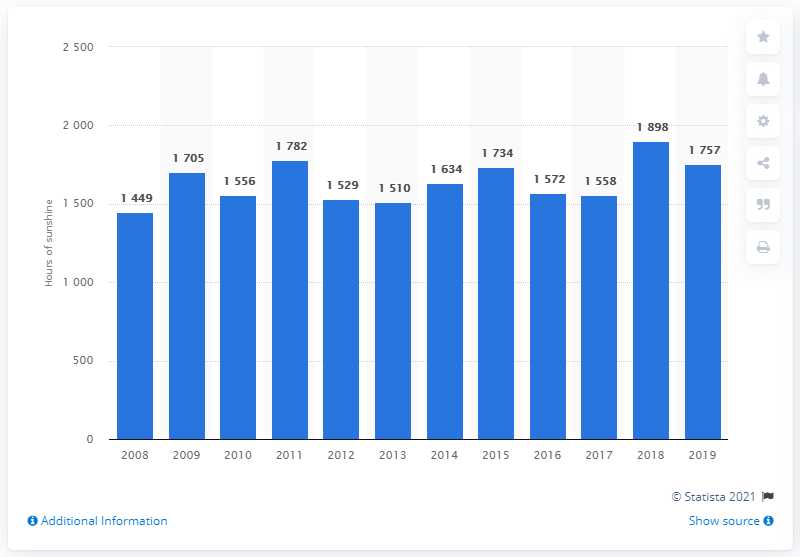Draw attention to some important aspects in this diagram. In 2018, Belgium experienced the sunniest year on record. 